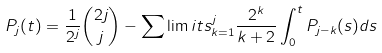<formula> <loc_0><loc_0><loc_500><loc_500>P _ { j } ( t ) = \frac { 1 } { 2 ^ { j } } \binom { 2 j } { j } - \sum \lim i t s _ { k = 1 } ^ { j } \frac { 2 ^ { k } } { k + 2 } \int _ { 0 } ^ { t } P _ { j - k } ( s ) d s</formula> 